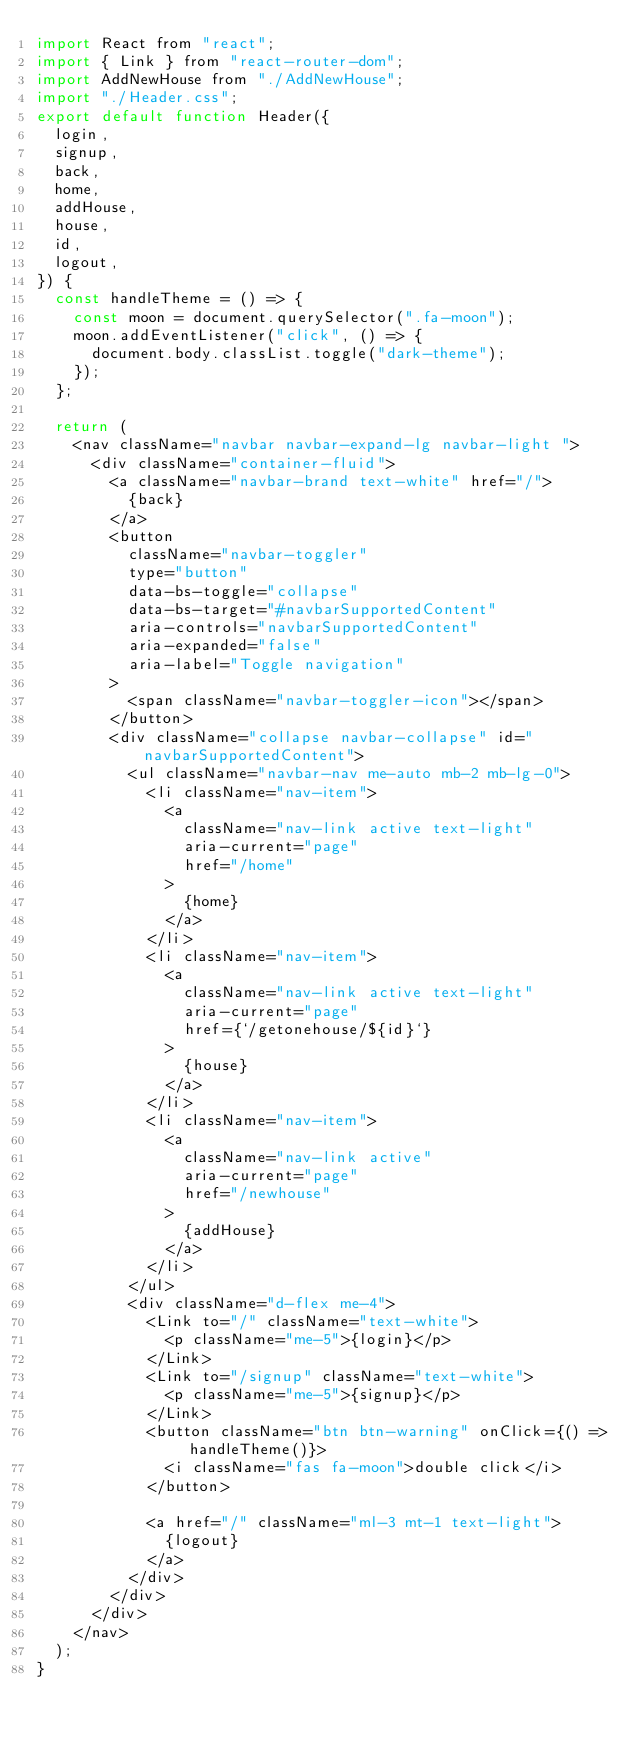Convert code to text. <code><loc_0><loc_0><loc_500><loc_500><_JavaScript_>import React from "react";
import { Link } from "react-router-dom";
import AddNewHouse from "./AddNewHouse";
import "./Header.css";
export default function Header({
  login,
  signup,
  back,
  home,
  addHouse,
  house,
  id,
  logout,
}) {
  const handleTheme = () => {
    const moon = document.querySelector(".fa-moon");
    moon.addEventListener("click", () => {
      document.body.classList.toggle("dark-theme");
    });
  };

  return (
    <nav className="navbar navbar-expand-lg navbar-light ">
      <div className="container-fluid">
        <a className="navbar-brand text-white" href="/">
          {back}
        </a>
        <button
          className="navbar-toggler"
          type="button"
          data-bs-toggle="collapse"
          data-bs-target="#navbarSupportedContent"
          aria-controls="navbarSupportedContent"
          aria-expanded="false"
          aria-label="Toggle navigation"
        >
          <span className="navbar-toggler-icon"></span>
        </button>
        <div className="collapse navbar-collapse" id="navbarSupportedContent">
          <ul className="navbar-nav me-auto mb-2 mb-lg-0">
            <li className="nav-item">
              <a
                className="nav-link active text-light"
                aria-current="page"
                href="/home"
              >
                {home}
              </a>
            </li>
            <li className="nav-item">
              <a
                className="nav-link active text-light"
                aria-current="page"
                href={`/getonehouse/${id}`}
              >
                {house}
              </a>
            </li>
            <li className="nav-item">
              <a
                className="nav-link active"
                aria-current="page"
                href="/newhouse"
              >
                {addHouse}
              </a>
            </li>
          </ul>
          <div className="d-flex me-4">
            <Link to="/" className="text-white">
              <p className="me-5">{login}</p>
            </Link>
            <Link to="/signup" className="text-white">
              <p className="me-5">{signup}</p>
            </Link>
            <button className="btn btn-warning" onClick={() => handleTheme()}>
              <i className="fas fa-moon">double click</i>
            </button>

            <a href="/" className="ml-3 mt-1 text-light">
              {logout}
            </a>
          </div>
        </div>
      </div>
    </nav>
  );
}
</code> 